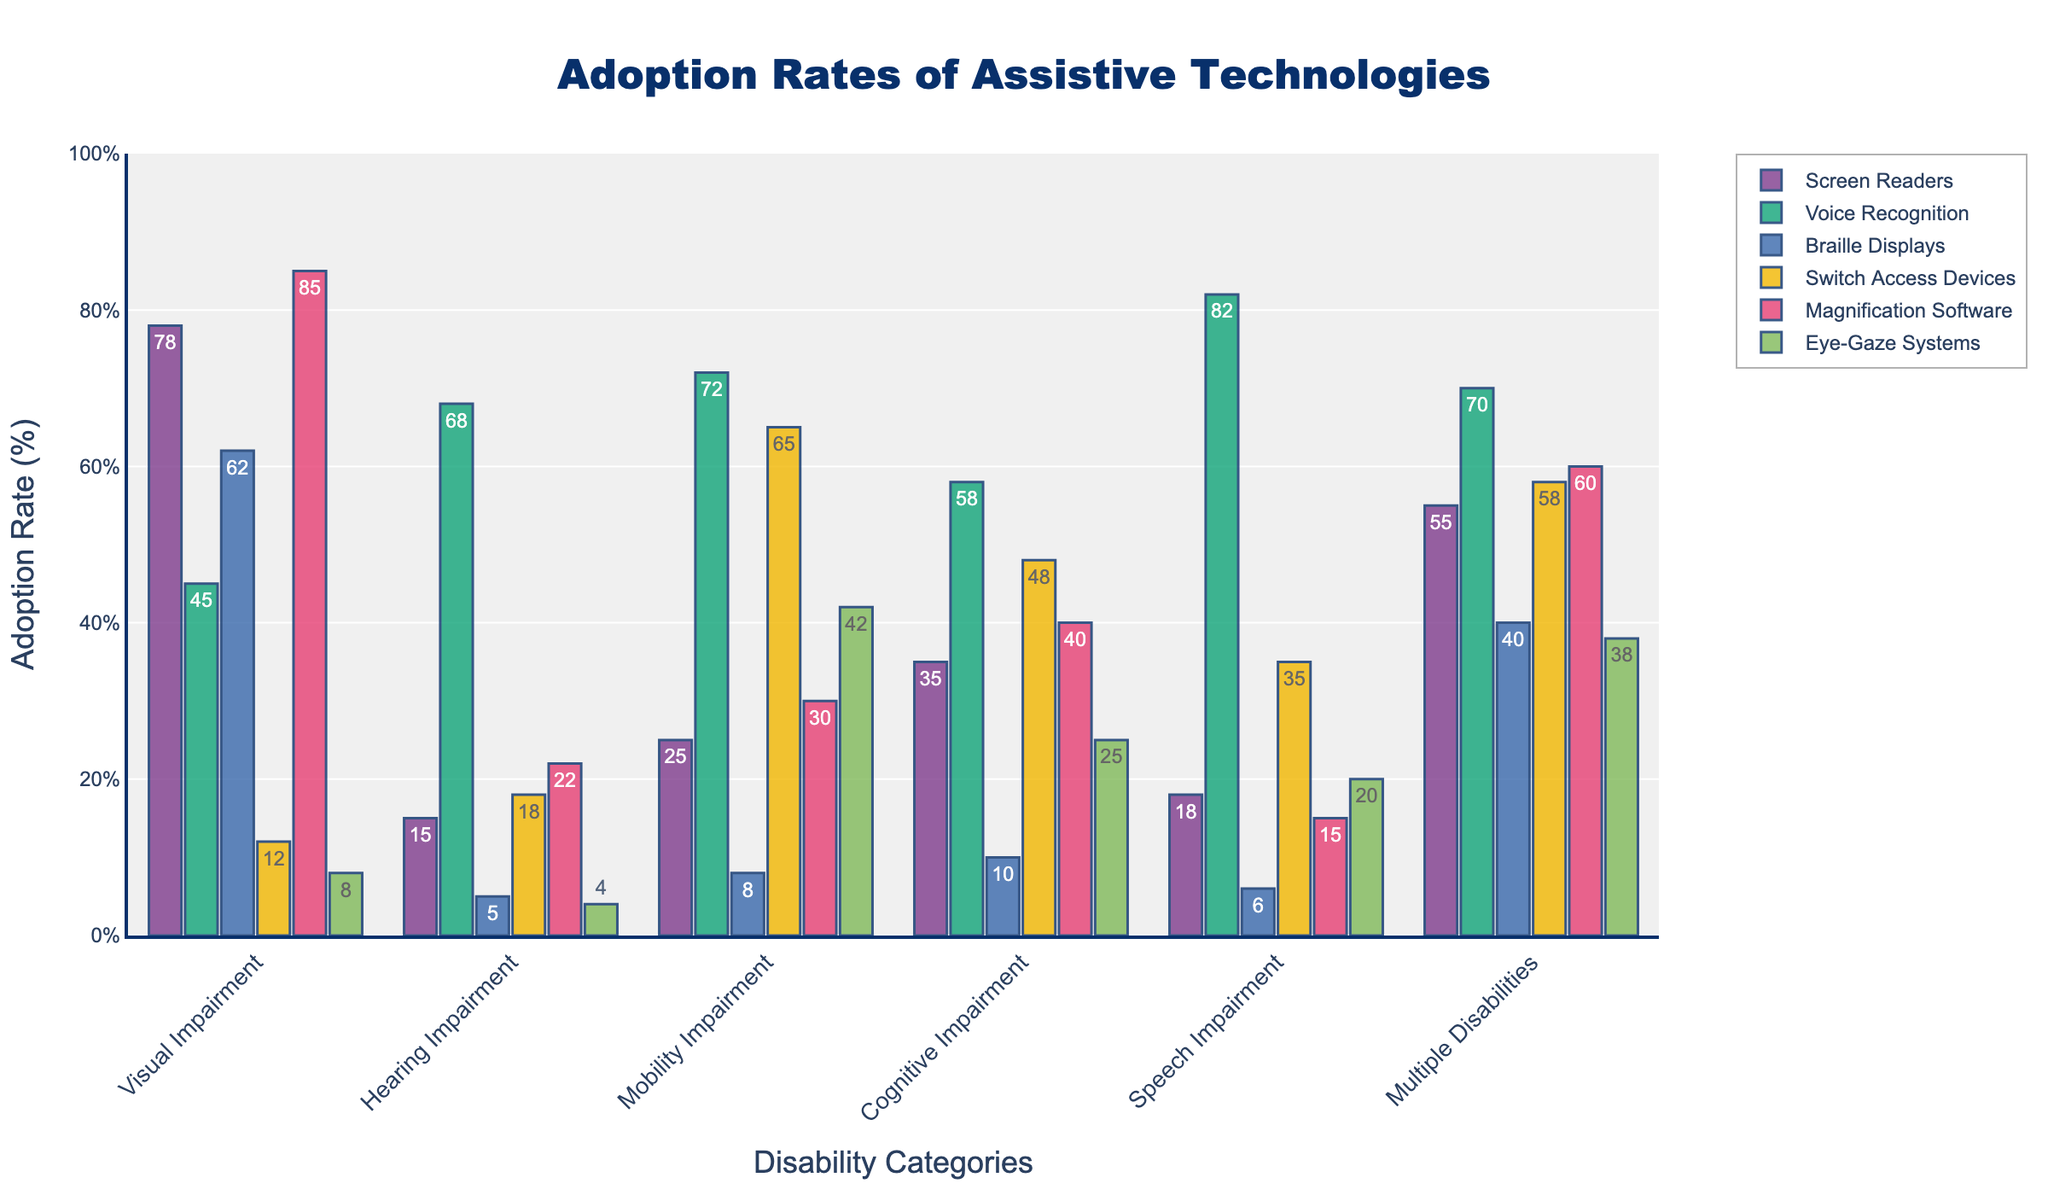Which disability category shows the highest adoption rate for Magnification Software? By observing the heights of the bars for Maginification Software across all disability categories, the tallest bar correlates with the Visual Impairment category.
Answer: Visual Impairment Which assistive technology has the lowest adoption rate for Visual Impairment? By comparing the different colored bars for Visual Impairment, Eye-Gaze Systems has the lowest height, indicating the lowest adoption rate.
Answer: Eye-Gaze Systems What is the total adoption rate for Switch Access Devices across all disability categories? By summing up the numbers for Switch Access Devices in each category (12+18+65+48+35+58), the total adoption rate is obtained.
Answer: 236 Which disability category has the most balanced adoption rates (less variation among technologies)? By visually comparing the heights of the bars for each disability category, the category with the most uniformly distributed bar heights is Multiple Disabilities.
Answer: Multiple Disabilities Between Screen Readers and Voice Recognition, which technology is used more by people with Mobility Impairment? By comparing the heights of the bars for Screen Readers and Voice Recognition in the Mobility Impairment category, Voice Recognition is taller.
Answer: Voice Recognition What is the average adoption rate of Braille Displays across Visual Impairment and Multiple Disabilities? By adding the adoption rates of Braille Displays for Visual Impairment (62) and Multiple Disabilities (40) and dividing by 2, the average adoption rate is calculated.
Answer: 51 How much higher is the adoption rate of Voice Recognition for Speech Impairment compared to Hearing Impairment? By subtracting the adoption rate of Voice Recognition for Hearing Impairment (68) from that for Speech Impairment (82), the difference is found.
Answer: 14 Which disability category has the highest adoption rate for Eye-Gaze Systems? By identifying the tallest bar for Eye-Gaze Systems across all categories, the highest is for Mobility Impairment.
Answer: Mobility Impairment Comparing the adoption rates for Screen Readers and Magnification Software across all categories, which technology tends to have higher adoption rates? By comparing the heights of the bars for Screen Readers and Magnification Software across all categories, Magnification Software generally has higher heights.
Answer: Magnification Software What is the difference between the highest and lowest adoption rates for Voice Recognition across all disability categories? By identifying the highest (Speech Impairment, 82) and lowest (Visual Impairment, 45) rates for Voice Recognition and calculating the difference (82 - 45), we find the result.
Answer: 37 